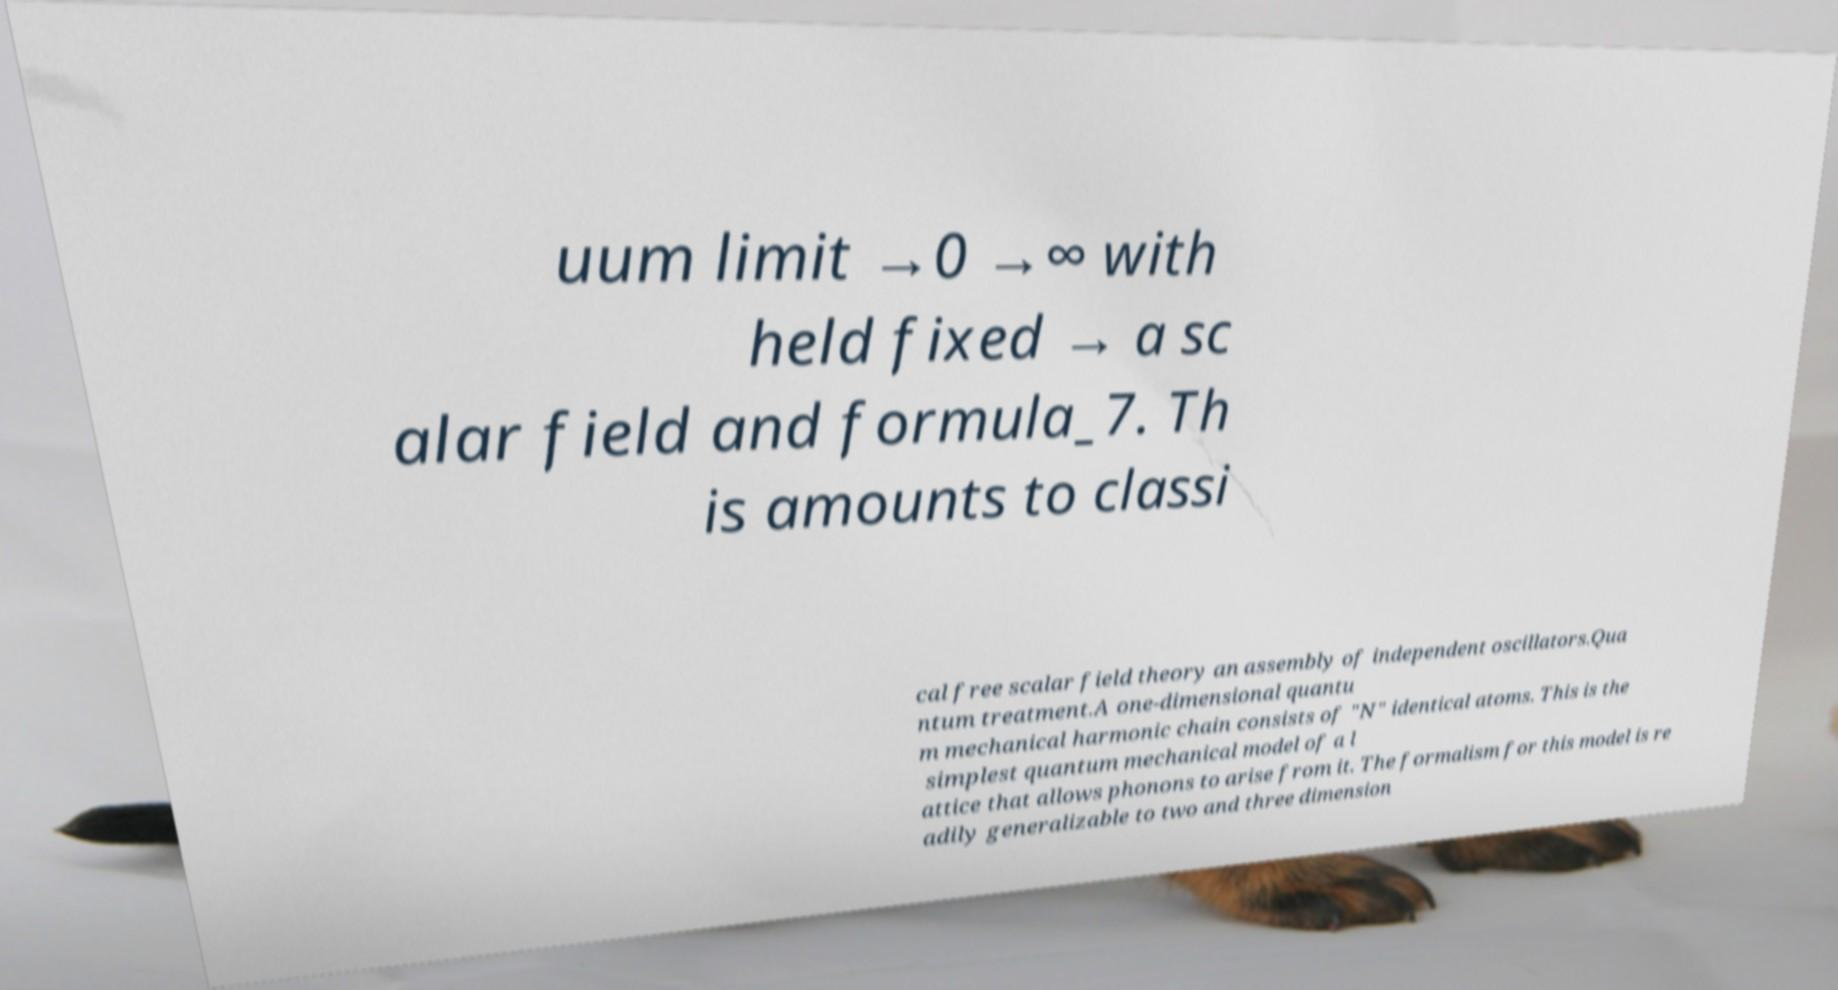Please read and relay the text visible in this image. What does it say? uum limit →0 →∞ with held fixed → a sc alar field and formula_7. Th is amounts to classi cal free scalar field theory an assembly of independent oscillators.Qua ntum treatment.A one-dimensional quantu m mechanical harmonic chain consists of "N" identical atoms. This is the simplest quantum mechanical model of a l attice that allows phonons to arise from it. The formalism for this model is re adily generalizable to two and three dimension 